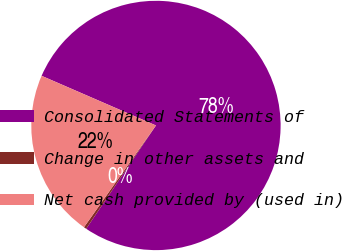Convert chart. <chart><loc_0><loc_0><loc_500><loc_500><pie_chart><fcel>Consolidated Statements of<fcel>Change in other assets and<fcel>Net cash provided by (used in)<nl><fcel>77.93%<fcel>0.34%<fcel>21.72%<nl></chart> 